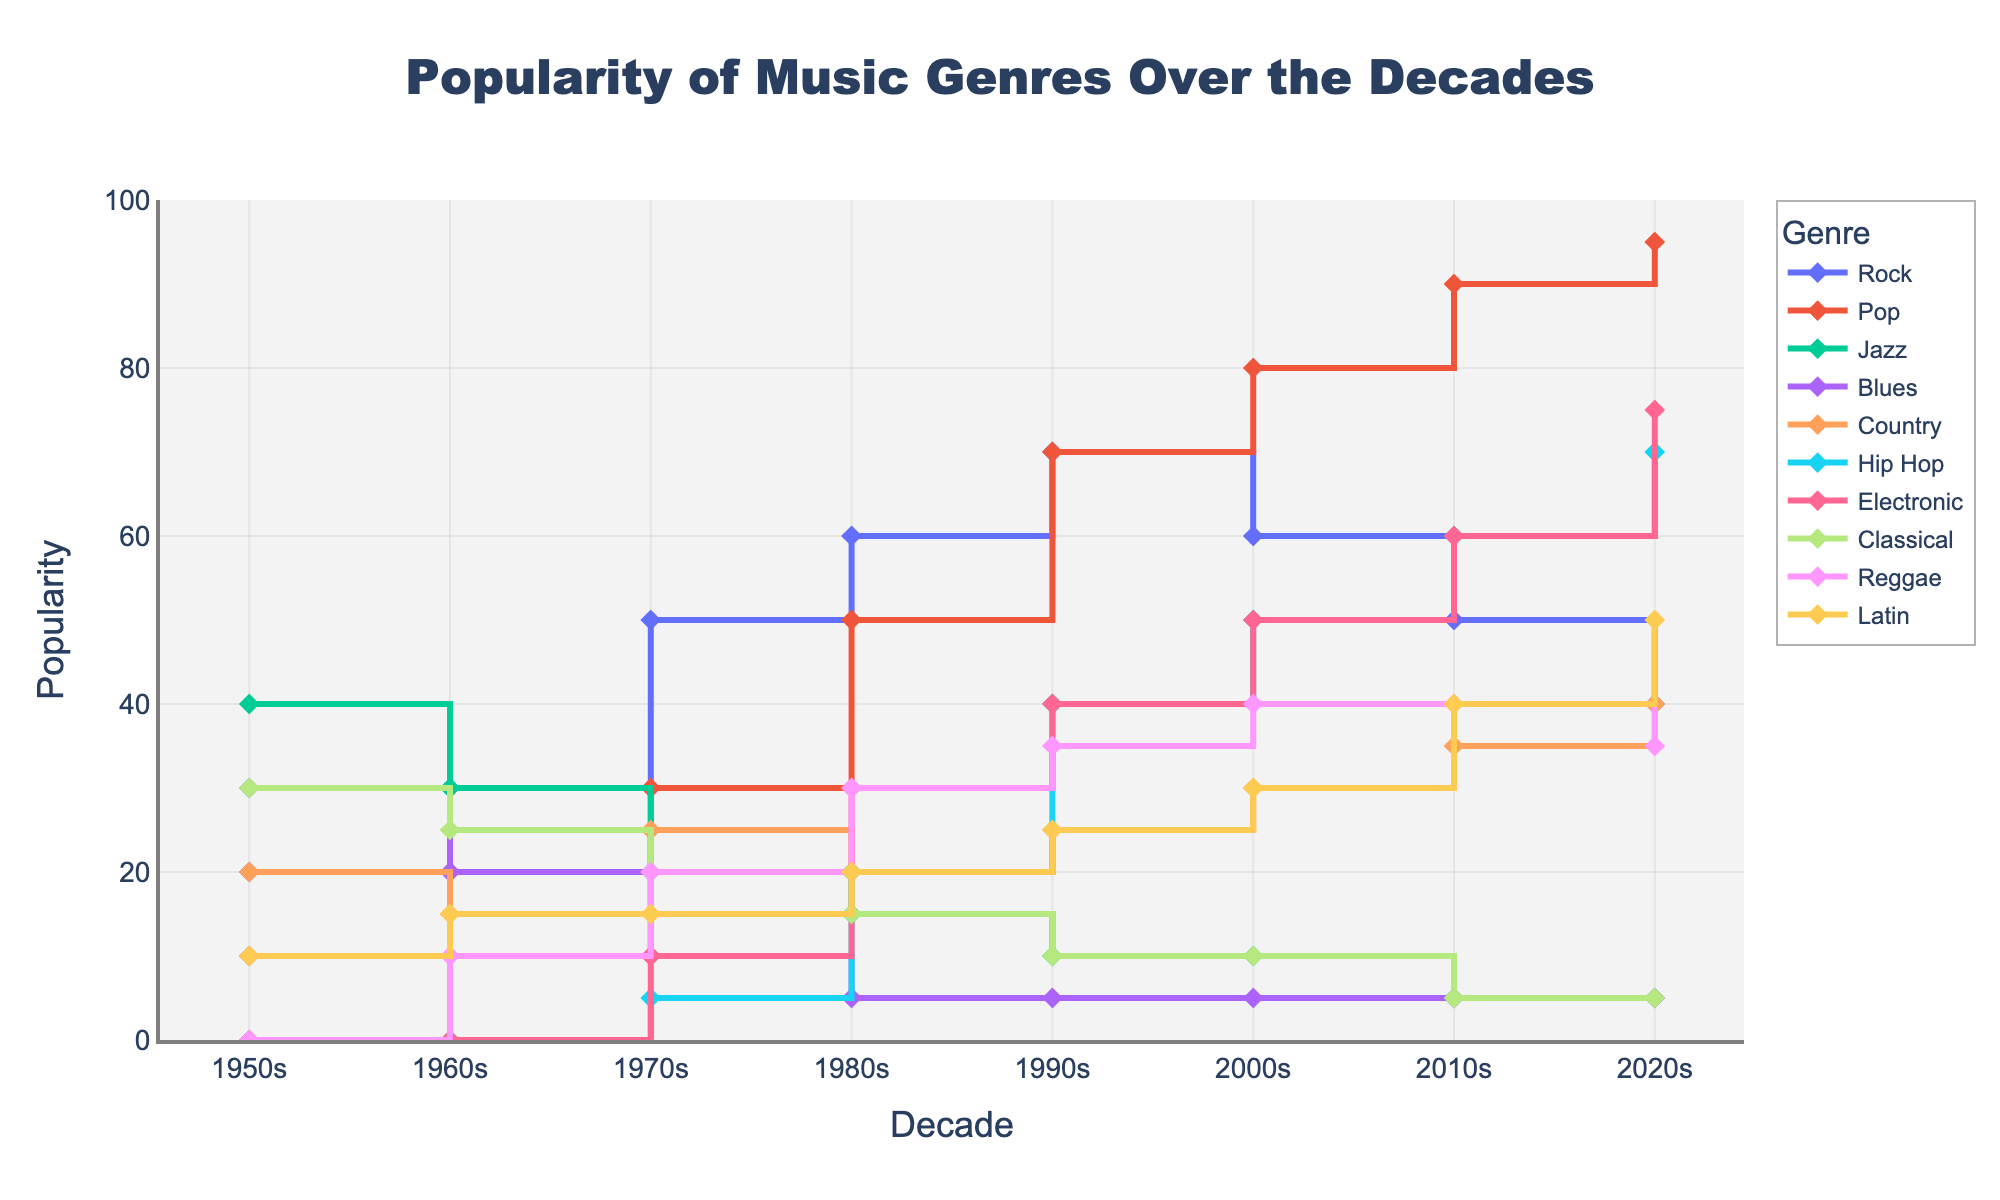What is the title of the figure? The title of the figure is located at the top and clearly states what the plot is about.
Answer: Popularity of Music Genres Over the Decades Which genre had the highest popularity in the 2020s? To determine this, look at the y-values (popularity) for each genre in the 2020s column and find the highest one.
Answer: Pop What is the general trend of Jazz music from the 1950s to the 2020s? Observe the trajectory of the Jazz line across the decades, noting how the popularity changes. It starts high and decreases over time.
Answer: Decreasing Compare the popularity of Hip Hop and Country in the 1980s. Which genre was more popular? Find the y-values for both Hip Hop and Country in the 1980s column and compare them.
Answer: Country How did the popularity of Classical music change from the 1950s to the 2020s? Trace the line corresponding to Classical music across the decades, noting the changes in popularity.
Answer: Decreased Which decade saw the greatest increase in popularity for Rock music? Look at the stair-like segments of the Rock line to find the decade with the steepest rise.
Answer: 1970s to 1980s What is the combined popularity of Latin and Electronic music in the 2010s? Add the popularity values of Latin and Electronic genres in the 2010s column.
Answer: 100 Which genre had a zero value in the 1950s and later saw a significant rise? Identify genres that had a zero value in the 1950s and then trace their lines to find a significant increase in subsequent decades.
Answer: Hip Hop How did the popularity of Blues music change over the decades? Observe the progression of the Blues line across the decades, noting any increases or decreases.
Answer: Decreased rapidly in the early decades and then stabilized What similarity can you find between the trends of Rock and Pop music over time? Compare both lines across all decades, noting any similarities in their shapes and trends. Both have a similar rise and fall pattern, but at different magnitudes and times.
Answer: Both generally increase, peak, and then decrease 